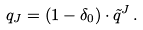<formula> <loc_0><loc_0><loc_500><loc_500>q _ { J } = ( 1 - \delta _ { 0 } ) \cdot \tilde { q } ^ { J } \, .</formula> 